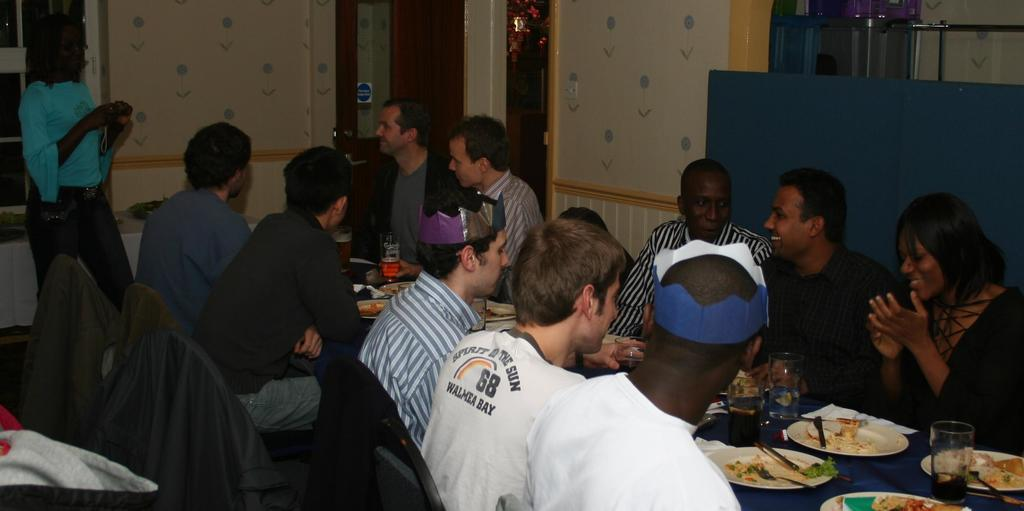<image>
Render a clear and concise summary of the photo. group of guys sitting having dinner, one wearing a shirt for walmea bay 